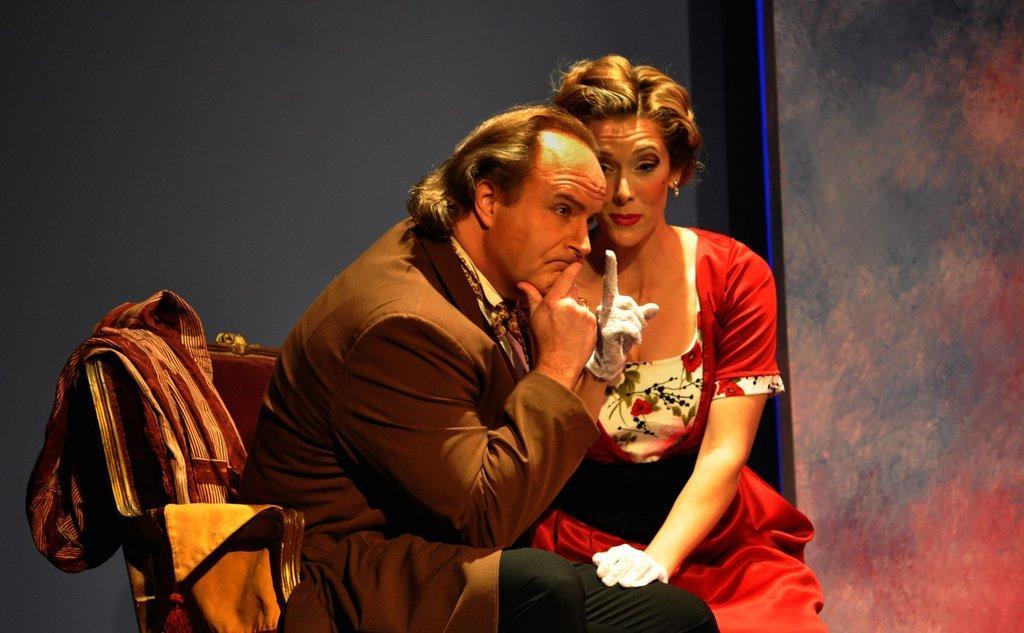Please provide a concise description of this image. in this given picture i can see two people sitting on a chair top of the chair i can see shawl which is available after that i can see a woman touching man's leg. 